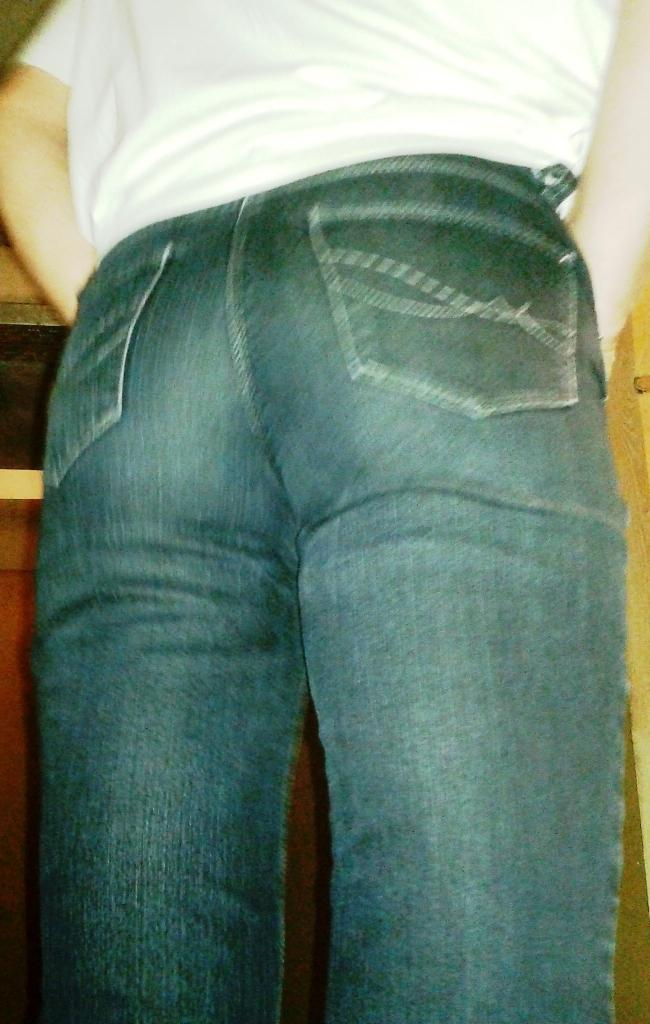What is present in the image? There is a person standing in the image. Can you describe the person's attire? The person is wearing clothes. What type of jelly can be seen on the person's tongue in the image? There is no jelly or reference to a tongue present in the image. What type of gate can be seen in the background of the image? There is no gate present in the image; it only features a person standing. 